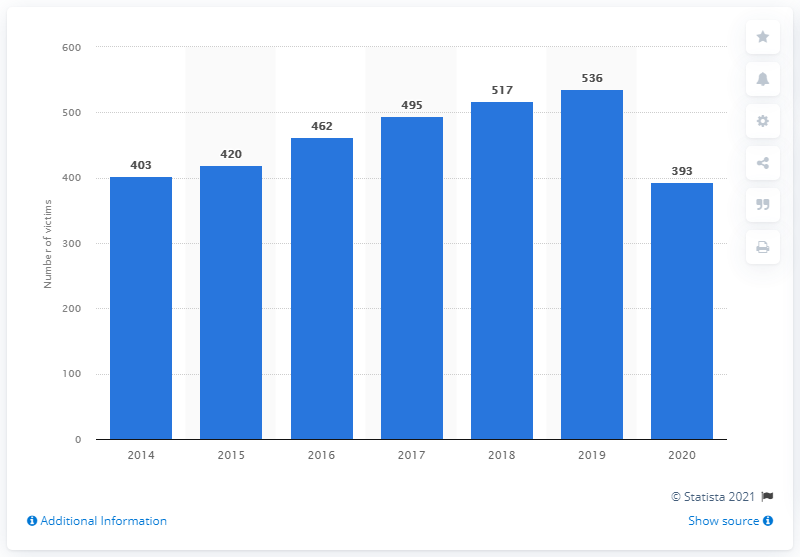Mention a couple of crucial points in this snapshot. Homicide levels in Trinidad and Tobago began to increase in 2014. The homicide rate in Trinidad and Tobago improved in 2020. In 2020, there were 393 murders reported in Trinidad and Tobago. 